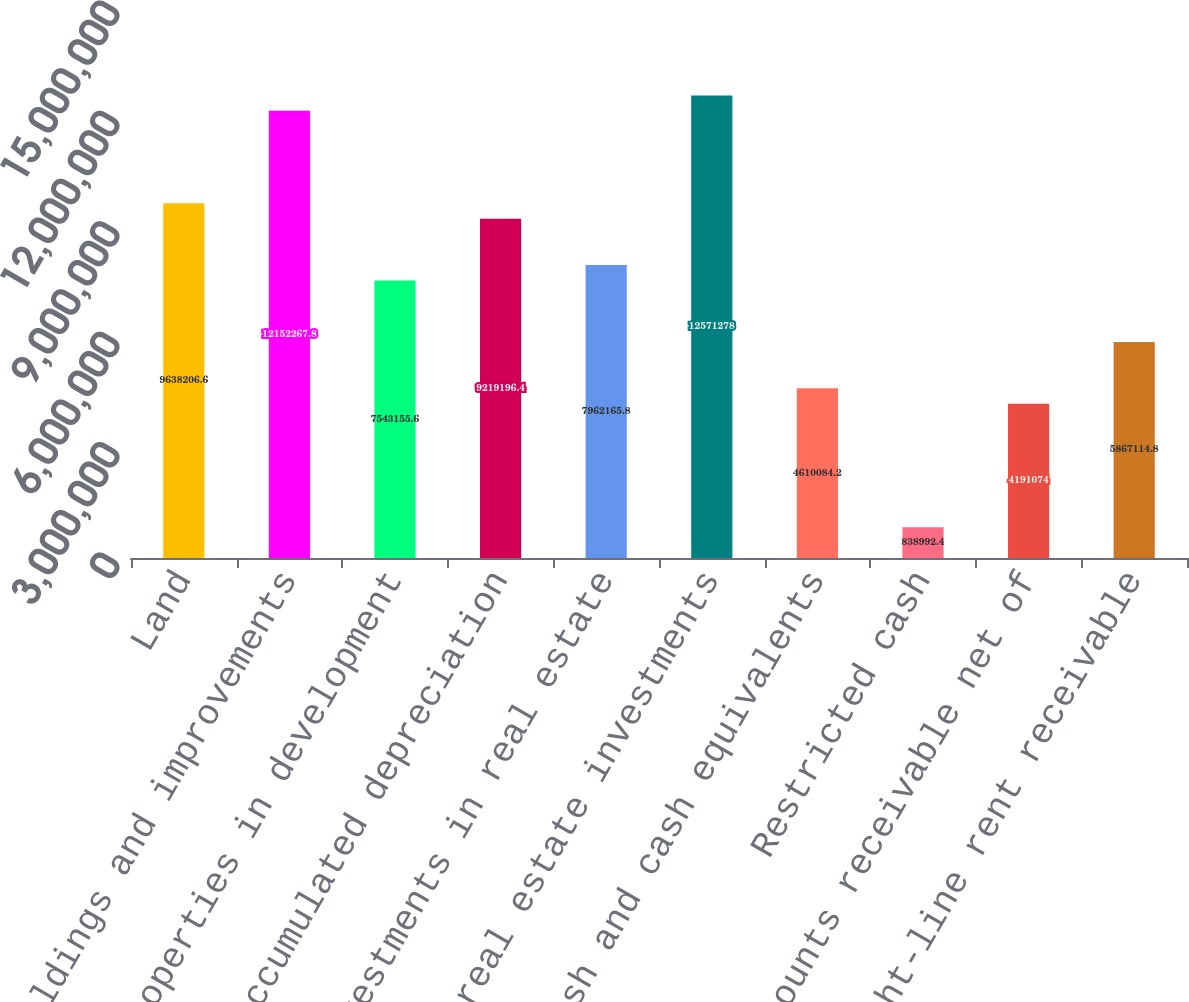Convert chart to OTSL. <chart><loc_0><loc_0><loc_500><loc_500><bar_chart><fcel>Land<fcel>Buildings and improvements<fcel>Properties in development<fcel>Less accumulated depreciation<fcel>Investments in real estate<fcel>Net real estate investments<fcel>Cash and cash equivalents<fcel>Restricted cash<fcel>Accounts receivable net of<fcel>Straight-line rent receivable<nl><fcel>9.63821e+06<fcel>1.21523e+07<fcel>7.54316e+06<fcel>9.2192e+06<fcel>7.96217e+06<fcel>1.25713e+07<fcel>4.61008e+06<fcel>838992<fcel>4.19107e+06<fcel>5.86711e+06<nl></chart> 